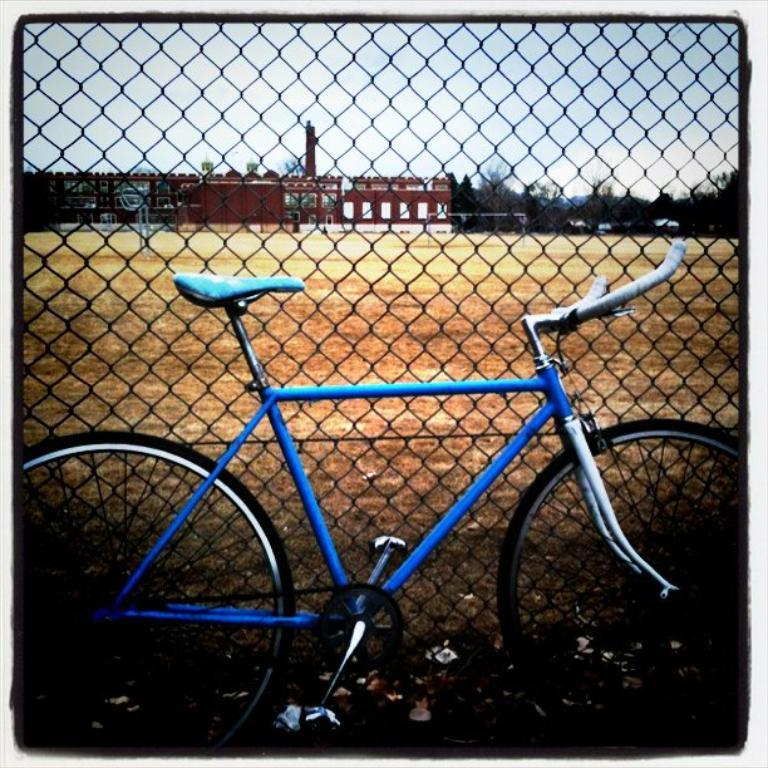What type of vehicle is in the image? There is a blue bicycle in the image. What can be seen in the background of the image? There is railing visible in the background. What is the color and type of the building in the image? There is a brown building in the image. What type of vegetation is present in the image? There are green trees in the image. What is the color of the sky in the image? The sky is blue and white in color. Can you tell me how many actors are swimming in the image? There are no actors or swimming depicted in the image; it features a blue bicycle, railing, a brown building, green trees, and a blue and white sky. 